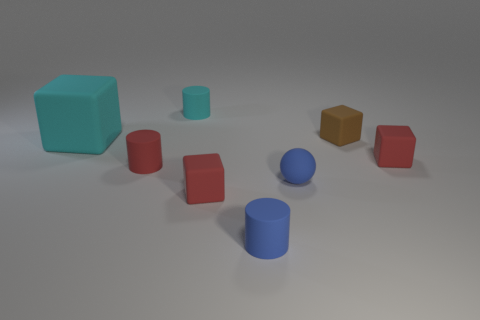How many tiny objects have the same color as the matte sphere?
Your response must be concise. 1. Do the small brown rubber thing and the tiny cyan rubber thing have the same shape?
Your answer should be compact. No. What number of matte objects are cyan cylinders or tiny balls?
Ensure brevity in your answer.  2. What material is the small thing that is the same color as the big thing?
Provide a succinct answer. Rubber. Is the size of the rubber sphere the same as the brown cube?
Make the answer very short. Yes. What number of things are either tiny matte balls or small rubber blocks behind the small blue matte ball?
Offer a very short reply. 3. There is a brown object that is the same size as the blue matte cylinder; what is its material?
Provide a succinct answer. Rubber. What material is the tiny thing that is left of the small blue cylinder and in front of the red cylinder?
Your answer should be very brief. Rubber. Are there any rubber cylinders behind the block right of the brown thing?
Your answer should be very brief. Yes. What is the size of the rubber cylinder that is both in front of the brown cube and left of the small blue matte cylinder?
Your response must be concise. Small. 